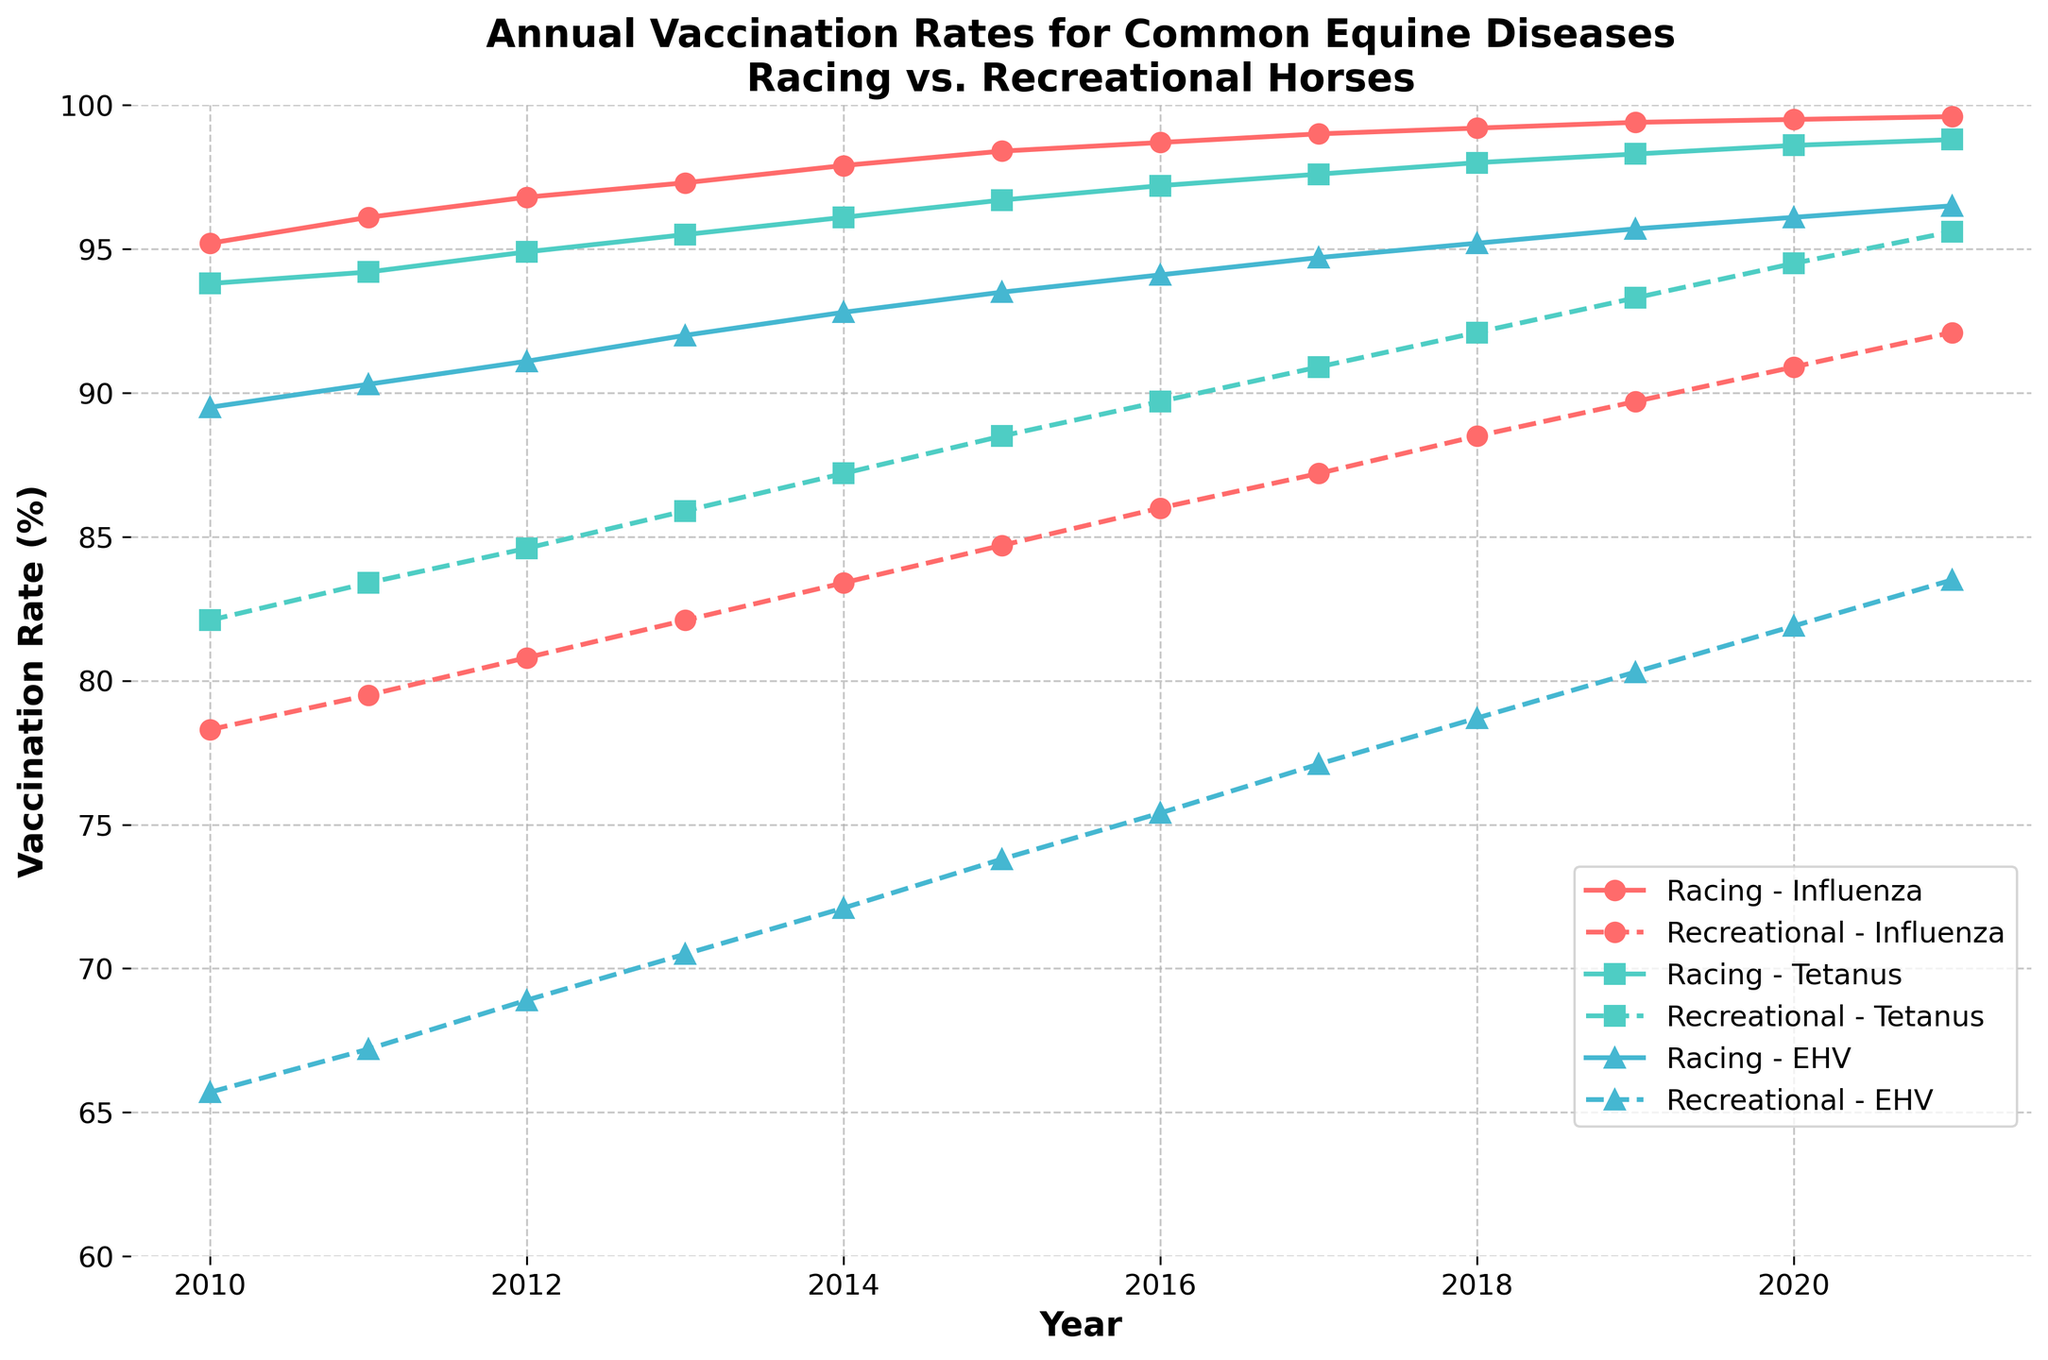What is the trend in vaccination rates for Influenza in racing horses over the years? To determine the trend, observe the line representing racing horses and Influenza. The line starts at 95.2% in 2010 and steadily increases each year, reaching 99.6% in 2021. This indicates a consistent upward trend.
Answer: Upward trend Which year had the highest vaccination rate for Tetanus in recreational horses? Locate the dashed line representing Tetanus for recreational horses. The highest point on this line occurs in 2021, where the vaccination rate reaches 95.6%.
Answer: 2021 Compare the vaccination rates for EHV between racing horses and recreational horses in 2015. Look at the values for EHV in 2015. Racing horses had a vaccination rate of 93.5%, while recreational horses had 73.8%. Thus, the rate is higher for racing horses.
Answer: Racing horses How much did the vaccination rate for Tetanus in recreational horses increase from 2010 to 2021? To find the increase, subtract the 2010 value from the 2021 value. The rate in 2021 is 95.6% and in 2010 is 82.1%, so the increase is 95.6 - 82.1 = 13.5%.
Answer: 13.5% What is the average vaccination rate for EHV in recreational horses between 2010 and 2021? To calculate the average, sum the yearly values and divide by the number of years. The values are 65.7, 67.2, 68.9, 70.5, 72.1, 73.8, 75.4, 77.1, 78.7, 80.3, 81.9, and 83.5, which sum to 915.1. Dividing by 12 gives an average of 76.26%.
Answer: 76.26% In which year did the vaccination rate for Influenza in recreational horses surpass 85% for the first time? Follow the dashed line representing Influenza in recreational horses and look for where it crosses 85%. This first occurs in 2017, where the rate is 87.2%.
Answer: 2017 Which disease showed the least year-to-year fluctuation in vaccination rates for racing horses? Observe the racing horses' lines for each disease. Influenza shows the least fluctuation, as its line is the smoothest and most steadily increasing, varying minimally year-to-year.
Answer: Influenza How does the overall trend for Tetanus vaccination in recreational horses compare to that in racing horses? The dashed line for recreational horses' Tetanus vaccinations increases steadily but starts lower and ends lower than the solid line for racing horses. Both lines show a consistent upward trend, though racing horses' vaccination rates are consistently higher.
Answer: Similar upward trend; racing horses higher How many years did it take for the EHV vaccination rate for racing horses to increase from 89.5% in 2010 to over 95%? Track the solid line for EHV in racing horses starting at 89.5% in 2010. It crosses 95% in 2018, taking from 2010 to 2018, which is 8 years.
Answer: 8 years 